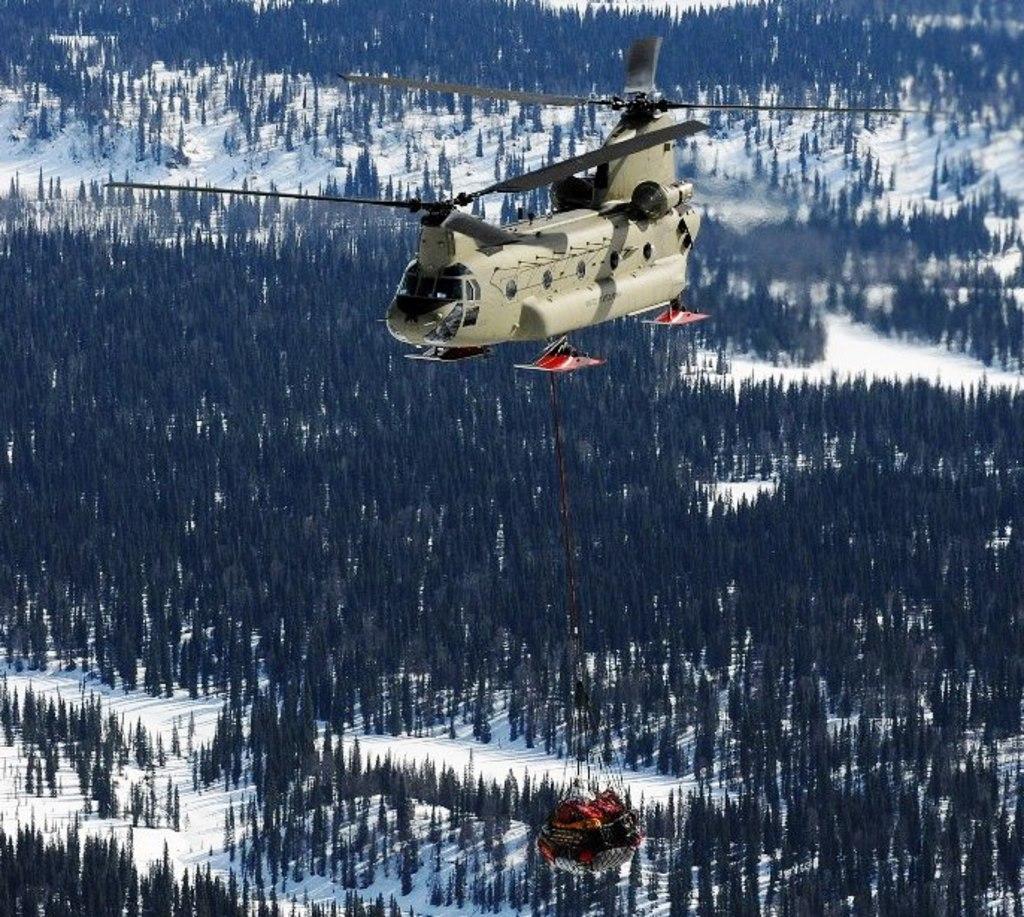In one or two sentences, can you explain what this image depicts? In this image there is helicopter flying in the sky and there is an object hanging. In the background there are trees and there is snow on the ground. 